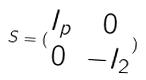<formula> <loc_0><loc_0><loc_500><loc_500>S = ( \begin{matrix} I _ { p } & 0 \\ 0 & - I _ { 2 } \end{matrix} )</formula> 